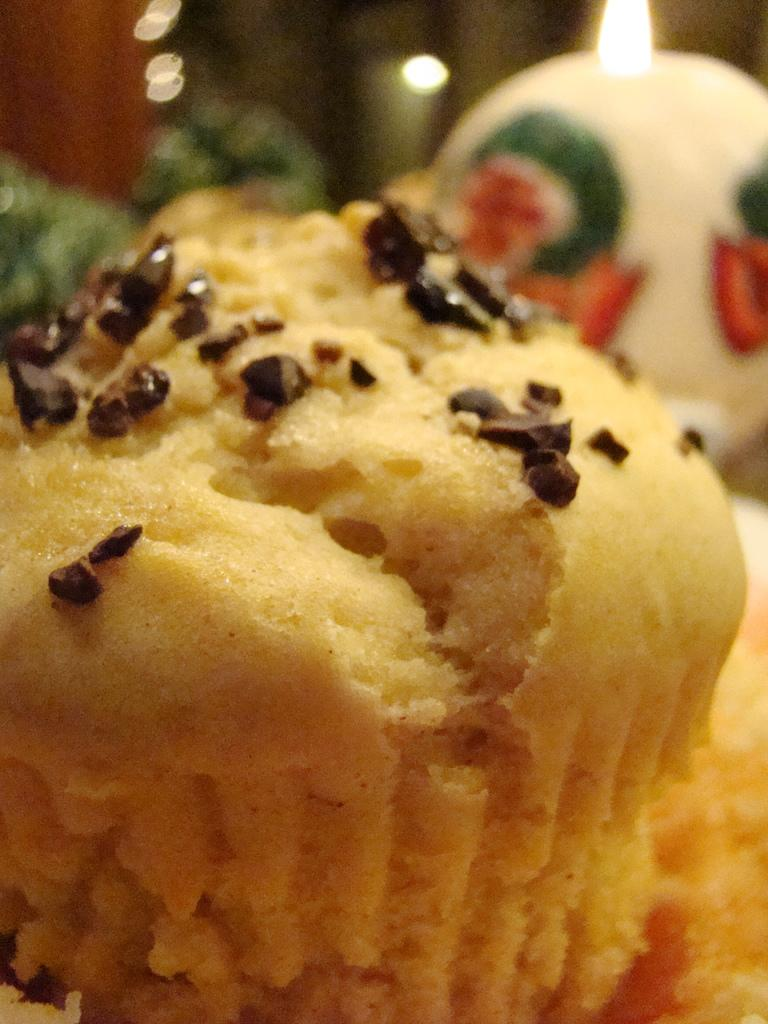What is the main subject of the image? The main subject of the image is food. Can you describe the background of the image? The background of the image is blurred. What type of glass is being offered to the person in the image? There is no person or glass present in the image; it only features food and a blurred background. 